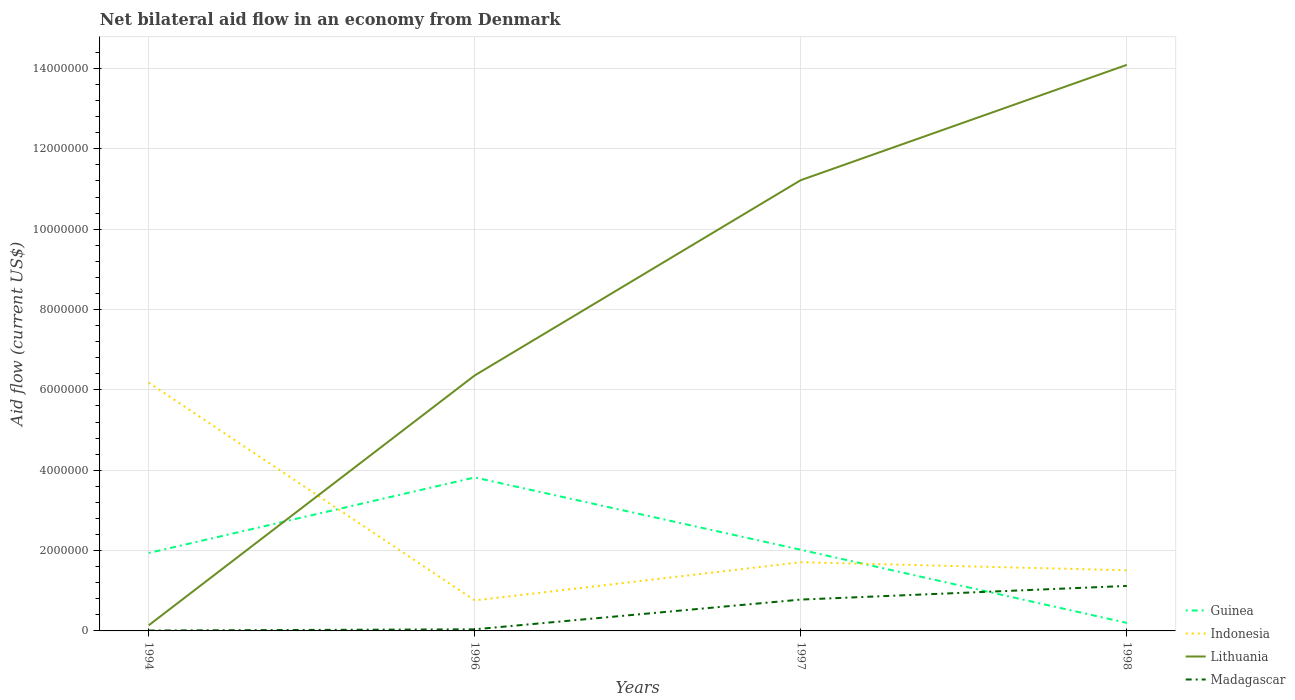How many different coloured lines are there?
Offer a terse response. 4. Is the number of lines equal to the number of legend labels?
Your answer should be compact. Yes. Across all years, what is the maximum net bilateral aid flow in Madagascar?
Offer a terse response. 10000. In which year was the net bilateral aid flow in Madagascar maximum?
Your response must be concise. 1994. What is the total net bilateral aid flow in Indonesia in the graph?
Make the answer very short. 4.67e+06. What is the difference between the highest and the second highest net bilateral aid flow in Lithuania?
Offer a terse response. 1.40e+07. How many lines are there?
Provide a short and direct response. 4. What is the difference between two consecutive major ticks on the Y-axis?
Your answer should be compact. 2.00e+06. Are the values on the major ticks of Y-axis written in scientific E-notation?
Make the answer very short. No. Does the graph contain any zero values?
Offer a very short reply. No. Does the graph contain grids?
Ensure brevity in your answer.  Yes. What is the title of the graph?
Offer a very short reply. Net bilateral aid flow in an economy from Denmark. What is the label or title of the X-axis?
Your answer should be compact. Years. What is the label or title of the Y-axis?
Make the answer very short. Aid flow (current US$). What is the Aid flow (current US$) of Guinea in 1994?
Give a very brief answer. 1.94e+06. What is the Aid flow (current US$) in Indonesia in 1994?
Provide a succinct answer. 6.18e+06. What is the Aid flow (current US$) of Lithuania in 1994?
Your response must be concise. 1.40e+05. What is the Aid flow (current US$) in Madagascar in 1994?
Your response must be concise. 10000. What is the Aid flow (current US$) of Guinea in 1996?
Your answer should be compact. 3.82e+06. What is the Aid flow (current US$) in Indonesia in 1996?
Ensure brevity in your answer.  7.60e+05. What is the Aid flow (current US$) in Lithuania in 1996?
Your answer should be very brief. 6.36e+06. What is the Aid flow (current US$) of Madagascar in 1996?
Keep it short and to the point. 4.00e+04. What is the Aid flow (current US$) of Guinea in 1997?
Make the answer very short. 2.02e+06. What is the Aid flow (current US$) in Indonesia in 1997?
Make the answer very short. 1.71e+06. What is the Aid flow (current US$) of Lithuania in 1997?
Provide a short and direct response. 1.12e+07. What is the Aid flow (current US$) in Madagascar in 1997?
Your response must be concise. 7.80e+05. What is the Aid flow (current US$) of Guinea in 1998?
Provide a short and direct response. 2.00e+05. What is the Aid flow (current US$) in Indonesia in 1998?
Give a very brief answer. 1.51e+06. What is the Aid flow (current US$) of Lithuania in 1998?
Ensure brevity in your answer.  1.41e+07. What is the Aid flow (current US$) of Madagascar in 1998?
Your answer should be compact. 1.12e+06. Across all years, what is the maximum Aid flow (current US$) of Guinea?
Offer a terse response. 3.82e+06. Across all years, what is the maximum Aid flow (current US$) in Indonesia?
Make the answer very short. 6.18e+06. Across all years, what is the maximum Aid flow (current US$) of Lithuania?
Provide a short and direct response. 1.41e+07. Across all years, what is the maximum Aid flow (current US$) in Madagascar?
Provide a succinct answer. 1.12e+06. Across all years, what is the minimum Aid flow (current US$) of Guinea?
Offer a very short reply. 2.00e+05. Across all years, what is the minimum Aid flow (current US$) in Indonesia?
Your answer should be compact. 7.60e+05. Across all years, what is the minimum Aid flow (current US$) of Lithuania?
Provide a short and direct response. 1.40e+05. Across all years, what is the minimum Aid flow (current US$) in Madagascar?
Your response must be concise. 10000. What is the total Aid flow (current US$) in Guinea in the graph?
Your response must be concise. 7.98e+06. What is the total Aid flow (current US$) in Indonesia in the graph?
Provide a short and direct response. 1.02e+07. What is the total Aid flow (current US$) in Lithuania in the graph?
Your answer should be very brief. 3.18e+07. What is the total Aid flow (current US$) of Madagascar in the graph?
Give a very brief answer. 1.95e+06. What is the difference between the Aid flow (current US$) of Guinea in 1994 and that in 1996?
Provide a succinct answer. -1.88e+06. What is the difference between the Aid flow (current US$) in Indonesia in 1994 and that in 1996?
Your response must be concise. 5.42e+06. What is the difference between the Aid flow (current US$) of Lithuania in 1994 and that in 1996?
Offer a terse response. -6.22e+06. What is the difference between the Aid flow (current US$) of Madagascar in 1994 and that in 1996?
Your answer should be compact. -3.00e+04. What is the difference between the Aid flow (current US$) in Indonesia in 1994 and that in 1997?
Provide a succinct answer. 4.47e+06. What is the difference between the Aid flow (current US$) in Lithuania in 1994 and that in 1997?
Your answer should be very brief. -1.11e+07. What is the difference between the Aid flow (current US$) of Madagascar in 1994 and that in 1997?
Your answer should be very brief. -7.70e+05. What is the difference between the Aid flow (current US$) in Guinea in 1994 and that in 1998?
Your response must be concise. 1.74e+06. What is the difference between the Aid flow (current US$) of Indonesia in 1994 and that in 1998?
Your answer should be compact. 4.67e+06. What is the difference between the Aid flow (current US$) of Lithuania in 1994 and that in 1998?
Give a very brief answer. -1.40e+07. What is the difference between the Aid flow (current US$) in Madagascar in 1994 and that in 1998?
Make the answer very short. -1.11e+06. What is the difference between the Aid flow (current US$) in Guinea in 1996 and that in 1997?
Ensure brevity in your answer.  1.80e+06. What is the difference between the Aid flow (current US$) in Indonesia in 1996 and that in 1997?
Provide a short and direct response. -9.50e+05. What is the difference between the Aid flow (current US$) of Lithuania in 1996 and that in 1997?
Offer a terse response. -4.86e+06. What is the difference between the Aid flow (current US$) in Madagascar in 1996 and that in 1997?
Your answer should be very brief. -7.40e+05. What is the difference between the Aid flow (current US$) in Guinea in 1996 and that in 1998?
Provide a short and direct response. 3.62e+06. What is the difference between the Aid flow (current US$) in Indonesia in 1996 and that in 1998?
Make the answer very short. -7.50e+05. What is the difference between the Aid flow (current US$) of Lithuania in 1996 and that in 1998?
Your answer should be very brief. -7.73e+06. What is the difference between the Aid flow (current US$) in Madagascar in 1996 and that in 1998?
Offer a very short reply. -1.08e+06. What is the difference between the Aid flow (current US$) of Guinea in 1997 and that in 1998?
Offer a very short reply. 1.82e+06. What is the difference between the Aid flow (current US$) in Indonesia in 1997 and that in 1998?
Your response must be concise. 2.00e+05. What is the difference between the Aid flow (current US$) of Lithuania in 1997 and that in 1998?
Make the answer very short. -2.87e+06. What is the difference between the Aid flow (current US$) of Madagascar in 1997 and that in 1998?
Your answer should be very brief. -3.40e+05. What is the difference between the Aid flow (current US$) in Guinea in 1994 and the Aid flow (current US$) in Indonesia in 1996?
Offer a terse response. 1.18e+06. What is the difference between the Aid flow (current US$) in Guinea in 1994 and the Aid flow (current US$) in Lithuania in 1996?
Make the answer very short. -4.42e+06. What is the difference between the Aid flow (current US$) in Guinea in 1994 and the Aid flow (current US$) in Madagascar in 1996?
Keep it short and to the point. 1.90e+06. What is the difference between the Aid flow (current US$) of Indonesia in 1994 and the Aid flow (current US$) of Lithuania in 1996?
Your answer should be very brief. -1.80e+05. What is the difference between the Aid flow (current US$) of Indonesia in 1994 and the Aid flow (current US$) of Madagascar in 1996?
Ensure brevity in your answer.  6.14e+06. What is the difference between the Aid flow (current US$) of Guinea in 1994 and the Aid flow (current US$) of Indonesia in 1997?
Offer a terse response. 2.30e+05. What is the difference between the Aid flow (current US$) in Guinea in 1994 and the Aid flow (current US$) in Lithuania in 1997?
Keep it short and to the point. -9.28e+06. What is the difference between the Aid flow (current US$) in Guinea in 1994 and the Aid flow (current US$) in Madagascar in 1997?
Your answer should be compact. 1.16e+06. What is the difference between the Aid flow (current US$) in Indonesia in 1994 and the Aid flow (current US$) in Lithuania in 1997?
Your answer should be very brief. -5.04e+06. What is the difference between the Aid flow (current US$) of Indonesia in 1994 and the Aid flow (current US$) of Madagascar in 1997?
Offer a terse response. 5.40e+06. What is the difference between the Aid flow (current US$) of Lithuania in 1994 and the Aid flow (current US$) of Madagascar in 1997?
Provide a succinct answer. -6.40e+05. What is the difference between the Aid flow (current US$) in Guinea in 1994 and the Aid flow (current US$) in Indonesia in 1998?
Offer a terse response. 4.30e+05. What is the difference between the Aid flow (current US$) of Guinea in 1994 and the Aid flow (current US$) of Lithuania in 1998?
Make the answer very short. -1.22e+07. What is the difference between the Aid flow (current US$) in Guinea in 1994 and the Aid flow (current US$) in Madagascar in 1998?
Ensure brevity in your answer.  8.20e+05. What is the difference between the Aid flow (current US$) of Indonesia in 1994 and the Aid flow (current US$) of Lithuania in 1998?
Provide a succinct answer. -7.91e+06. What is the difference between the Aid flow (current US$) in Indonesia in 1994 and the Aid flow (current US$) in Madagascar in 1998?
Provide a short and direct response. 5.06e+06. What is the difference between the Aid flow (current US$) in Lithuania in 1994 and the Aid flow (current US$) in Madagascar in 1998?
Your answer should be compact. -9.80e+05. What is the difference between the Aid flow (current US$) of Guinea in 1996 and the Aid flow (current US$) of Indonesia in 1997?
Make the answer very short. 2.11e+06. What is the difference between the Aid flow (current US$) in Guinea in 1996 and the Aid flow (current US$) in Lithuania in 1997?
Offer a terse response. -7.40e+06. What is the difference between the Aid flow (current US$) of Guinea in 1996 and the Aid flow (current US$) of Madagascar in 1997?
Make the answer very short. 3.04e+06. What is the difference between the Aid flow (current US$) of Indonesia in 1996 and the Aid flow (current US$) of Lithuania in 1997?
Your answer should be very brief. -1.05e+07. What is the difference between the Aid flow (current US$) of Lithuania in 1996 and the Aid flow (current US$) of Madagascar in 1997?
Offer a very short reply. 5.58e+06. What is the difference between the Aid flow (current US$) in Guinea in 1996 and the Aid flow (current US$) in Indonesia in 1998?
Ensure brevity in your answer.  2.31e+06. What is the difference between the Aid flow (current US$) in Guinea in 1996 and the Aid flow (current US$) in Lithuania in 1998?
Offer a terse response. -1.03e+07. What is the difference between the Aid flow (current US$) in Guinea in 1996 and the Aid flow (current US$) in Madagascar in 1998?
Your answer should be very brief. 2.70e+06. What is the difference between the Aid flow (current US$) in Indonesia in 1996 and the Aid flow (current US$) in Lithuania in 1998?
Provide a succinct answer. -1.33e+07. What is the difference between the Aid flow (current US$) in Indonesia in 1996 and the Aid flow (current US$) in Madagascar in 1998?
Provide a succinct answer. -3.60e+05. What is the difference between the Aid flow (current US$) in Lithuania in 1996 and the Aid flow (current US$) in Madagascar in 1998?
Provide a succinct answer. 5.24e+06. What is the difference between the Aid flow (current US$) in Guinea in 1997 and the Aid flow (current US$) in Indonesia in 1998?
Your answer should be compact. 5.10e+05. What is the difference between the Aid flow (current US$) in Guinea in 1997 and the Aid flow (current US$) in Lithuania in 1998?
Your answer should be very brief. -1.21e+07. What is the difference between the Aid flow (current US$) in Indonesia in 1997 and the Aid flow (current US$) in Lithuania in 1998?
Make the answer very short. -1.24e+07. What is the difference between the Aid flow (current US$) of Indonesia in 1997 and the Aid flow (current US$) of Madagascar in 1998?
Your answer should be compact. 5.90e+05. What is the difference between the Aid flow (current US$) of Lithuania in 1997 and the Aid flow (current US$) of Madagascar in 1998?
Make the answer very short. 1.01e+07. What is the average Aid flow (current US$) in Guinea per year?
Your answer should be compact. 2.00e+06. What is the average Aid flow (current US$) in Indonesia per year?
Offer a very short reply. 2.54e+06. What is the average Aid flow (current US$) of Lithuania per year?
Provide a succinct answer. 7.95e+06. What is the average Aid flow (current US$) of Madagascar per year?
Offer a very short reply. 4.88e+05. In the year 1994, what is the difference between the Aid flow (current US$) of Guinea and Aid flow (current US$) of Indonesia?
Your answer should be compact. -4.24e+06. In the year 1994, what is the difference between the Aid flow (current US$) of Guinea and Aid flow (current US$) of Lithuania?
Provide a succinct answer. 1.80e+06. In the year 1994, what is the difference between the Aid flow (current US$) in Guinea and Aid flow (current US$) in Madagascar?
Your answer should be compact. 1.93e+06. In the year 1994, what is the difference between the Aid flow (current US$) in Indonesia and Aid flow (current US$) in Lithuania?
Provide a short and direct response. 6.04e+06. In the year 1994, what is the difference between the Aid flow (current US$) of Indonesia and Aid flow (current US$) of Madagascar?
Keep it short and to the point. 6.17e+06. In the year 1996, what is the difference between the Aid flow (current US$) of Guinea and Aid flow (current US$) of Indonesia?
Your answer should be very brief. 3.06e+06. In the year 1996, what is the difference between the Aid flow (current US$) of Guinea and Aid flow (current US$) of Lithuania?
Ensure brevity in your answer.  -2.54e+06. In the year 1996, what is the difference between the Aid flow (current US$) of Guinea and Aid flow (current US$) of Madagascar?
Provide a short and direct response. 3.78e+06. In the year 1996, what is the difference between the Aid flow (current US$) of Indonesia and Aid flow (current US$) of Lithuania?
Your response must be concise. -5.60e+06. In the year 1996, what is the difference between the Aid flow (current US$) of Indonesia and Aid flow (current US$) of Madagascar?
Provide a succinct answer. 7.20e+05. In the year 1996, what is the difference between the Aid flow (current US$) in Lithuania and Aid flow (current US$) in Madagascar?
Offer a terse response. 6.32e+06. In the year 1997, what is the difference between the Aid flow (current US$) of Guinea and Aid flow (current US$) of Lithuania?
Your answer should be compact. -9.20e+06. In the year 1997, what is the difference between the Aid flow (current US$) of Guinea and Aid flow (current US$) of Madagascar?
Make the answer very short. 1.24e+06. In the year 1997, what is the difference between the Aid flow (current US$) of Indonesia and Aid flow (current US$) of Lithuania?
Offer a terse response. -9.51e+06. In the year 1997, what is the difference between the Aid flow (current US$) in Indonesia and Aid flow (current US$) in Madagascar?
Keep it short and to the point. 9.30e+05. In the year 1997, what is the difference between the Aid flow (current US$) of Lithuania and Aid flow (current US$) of Madagascar?
Offer a very short reply. 1.04e+07. In the year 1998, what is the difference between the Aid flow (current US$) of Guinea and Aid flow (current US$) of Indonesia?
Provide a short and direct response. -1.31e+06. In the year 1998, what is the difference between the Aid flow (current US$) of Guinea and Aid flow (current US$) of Lithuania?
Your answer should be very brief. -1.39e+07. In the year 1998, what is the difference between the Aid flow (current US$) in Guinea and Aid flow (current US$) in Madagascar?
Offer a terse response. -9.20e+05. In the year 1998, what is the difference between the Aid flow (current US$) of Indonesia and Aid flow (current US$) of Lithuania?
Your response must be concise. -1.26e+07. In the year 1998, what is the difference between the Aid flow (current US$) of Indonesia and Aid flow (current US$) of Madagascar?
Ensure brevity in your answer.  3.90e+05. In the year 1998, what is the difference between the Aid flow (current US$) in Lithuania and Aid flow (current US$) in Madagascar?
Offer a terse response. 1.30e+07. What is the ratio of the Aid flow (current US$) in Guinea in 1994 to that in 1996?
Ensure brevity in your answer.  0.51. What is the ratio of the Aid flow (current US$) in Indonesia in 1994 to that in 1996?
Offer a very short reply. 8.13. What is the ratio of the Aid flow (current US$) in Lithuania in 1994 to that in 1996?
Your answer should be compact. 0.02. What is the ratio of the Aid flow (current US$) in Guinea in 1994 to that in 1997?
Your answer should be compact. 0.96. What is the ratio of the Aid flow (current US$) in Indonesia in 1994 to that in 1997?
Your response must be concise. 3.61. What is the ratio of the Aid flow (current US$) in Lithuania in 1994 to that in 1997?
Your answer should be compact. 0.01. What is the ratio of the Aid flow (current US$) of Madagascar in 1994 to that in 1997?
Provide a short and direct response. 0.01. What is the ratio of the Aid flow (current US$) of Indonesia in 1994 to that in 1998?
Make the answer very short. 4.09. What is the ratio of the Aid flow (current US$) of Lithuania in 1994 to that in 1998?
Offer a terse response. 0.01. What is the ratio of the Aid flow (current US$) in Madagascar in 1994 to that in 1998?
Provide a succinct answer. 0.01. What is the ratio of the Aid flow (current US$) in Guinea in 1996 to that in 1997?
Give a very brief answer. 1.89. What is the ratio of the Aid flow (current US$) of Indonesia in 1996 to that in 1997?
Keep it short and to the point. 0.44. What is the ratio of the Aid flow (current US$) of Lithuania in 1996 to that in 1997?
Keep it short and to the point. 0.57. What is the ratio of the Aid flow (current US$) of Madagascar in 1996 to that in 1997?
Provide a succinct answer. 0.05. What is the ratio of the Aid flow (current US$) in Guinea in 1996 to that in 1998?
Offer a terse response. 19.1. What is the ratio of the Aid flow (current US$) in Indonesia in 1996 to that in 1998?
Offer a terse response. 0.5. What is the ratio of the Aid flow (current US$) in Lithuania in 1996 to that in 1998?
Ensure brevity in your answer.  0.45. What is the ratio of the Aid flow (current US$) of Madagascar in 1996 to that in 1998?
Provide a short and direct response. 0.04. What is the ratio of the Aid flow (current US$) of Indonesia in 1997 to that in 1998?
Offer a very short reply. 1.13. What is the ratio of the Aid flow (current US$) in Lithuania in 1997 to that in 1998?
Your answer should be very brief. 0.8. What is the ratio of the Aid flow (current US$) of Madagascar in 1997 to that in 1998?
Your answer should be compact. 0.7. What is the difference between the highest and the second highest Aid flow (current US$) in Guinea?
Your answer should be very brief. 1.80e+06. What is the difference between the highest and the second highest Aid flow (current US$) in Indonesia?
Keep it short and to the point. 4.47e+06. What is the difference between the highest and the second highest Aid flow (current US$) in Lithuania?
Make the answer very short. 2.87e+06. What is the difference between the highest and the lowest Aid flow (current US$) in Guinea?
Your answer should be very brief. 3.62e+06. What is the difference between the highest and the lowest Aid flow (current US$) in Indonesia?
Your answer should be compact. 5.42e+06. What is the difference between the highest and the lowest Aid flow (current US$) in Lithuania?
Provide a short and direct response. 1.40e+07. What is the difference between the highest and the lowest Aid flow (current US$) in Madagascar?
Offer a very short reply. 1.11e+06. 